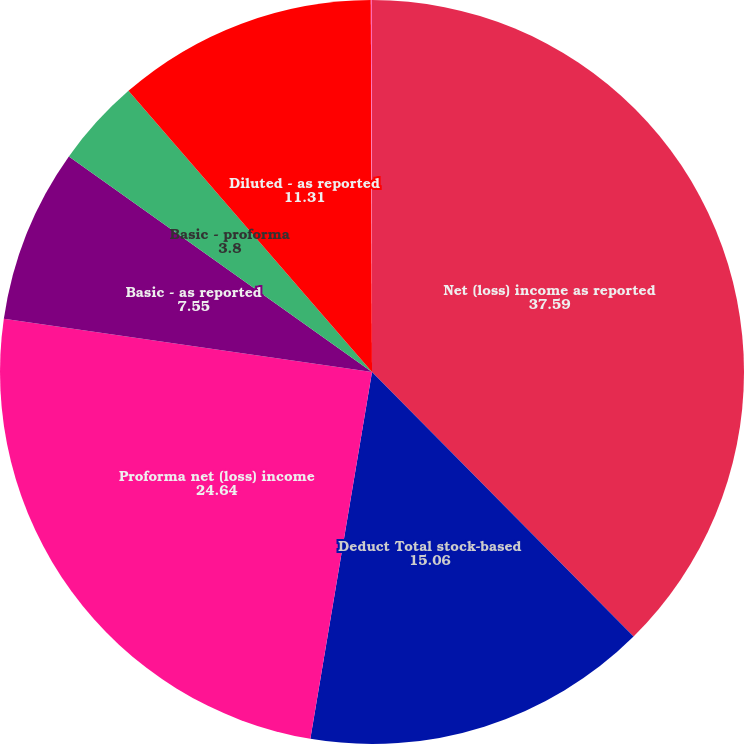<chart> <loc_0><loc_0><loc_500><loc_500><pie_chart><fcel>Net (loss) income as reported<fcel>Deduct Total stock-based<fcel>Proforma net (loss) income<fcel>Basic - as reported<fcel>Basic - proforma<fcel>Diluted - as reported<fcel>Diluted - proforma<nl><fcel>37.59%<fcel>15.06%<fcel>24.64%<fcel>7.55%<fcel>3.8%<fcel>11.31%<fcel>0.05%<nl></chart> 